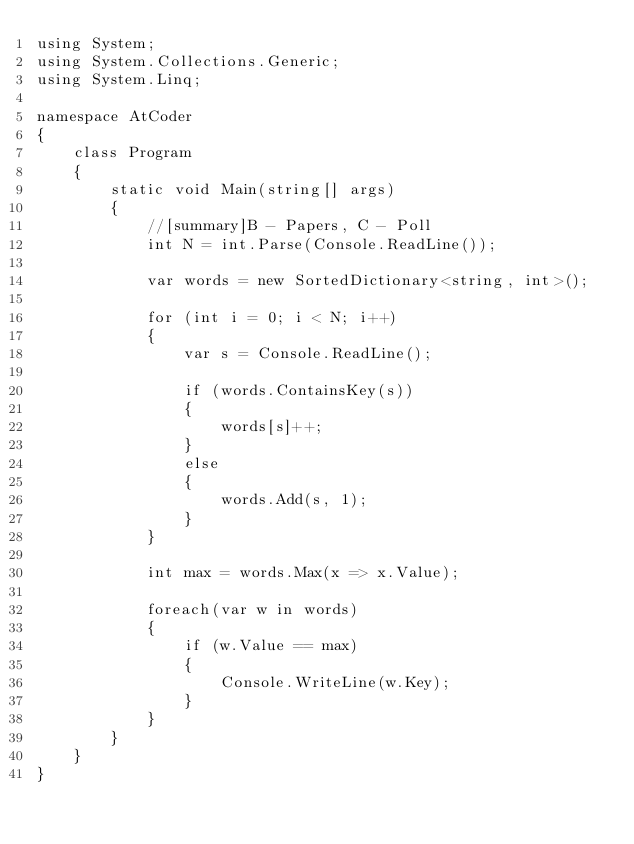Convert code to text. <code><loc_0><loc_0><loc_500><loc_500><_C#_>using System;
using System.Collections.Generic;
using System.Linq;

namespace AtCoder
{
    class Program
    {
        static void Main(string[] args)
        {
            //[summary]B - Papers, C - Poll
            int N = int.Parse(Console.ReadLine());

            var words = new SortedDictionary<string, int>();

            for (int i = 0; i < N; i++)
            {
                var s = Console.ReadLine();

                if (words.ContainsKey(s))
                {
                    words[s]++;
                }
                else
                {
                    words.Add(s, 1);
                }
            }

            int max = words.Max(x => x.Value);

            foreach(var w in words)
            {
                if (w.Value == max)
                {
                    Console.WriteLine(w.Key);
                }
            }
        }
    }
}</code> 